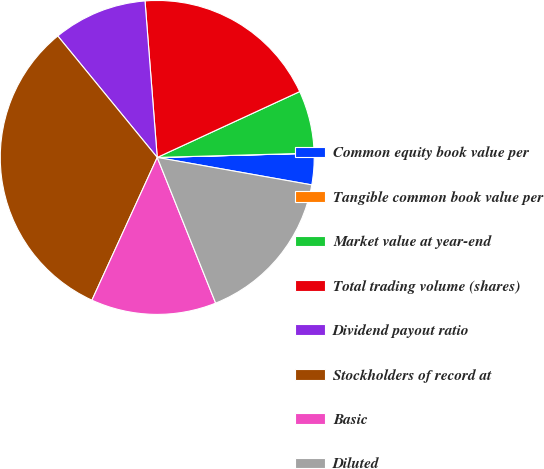Convert chart. <chart><loc_0><loc_0><loc_500><loc_500><pie_chart><fcel>Common equity book value per<fcel>Tangible common book value per<fcel>Market value at year-end<fcel>Total trading volume (shares)<fcel>Dividend payout ratio<fcel>Stockholders of record at<fcel>Basic<fcel>Diluted<nl><fcel>3.23%<fcel>0.01%<fcel>6.45%<fcel>19.35%<fcel>9.68%<fcel>32.25%<fcel>12.9%<fcel>16.13%<nl></chart> 